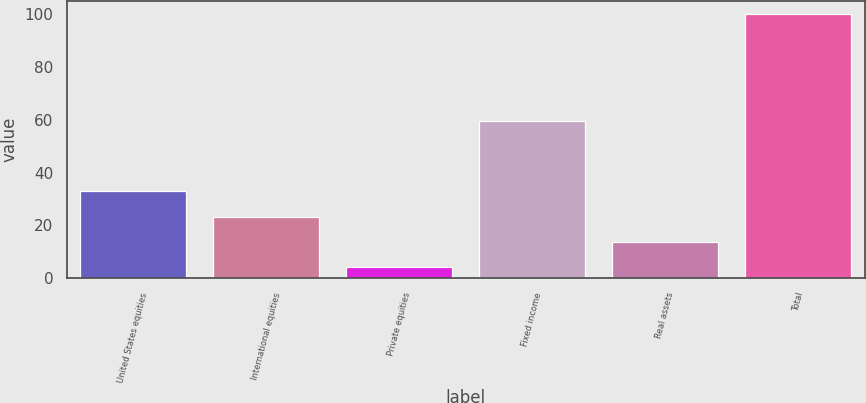Convert chart to OTSL. <chart><loc_0><loc_0><loc_500><loc_500><bar_chart><fcel>United States equities<fcel>International equities<fcel>Private equities<fcel>Fixed income<fcel>Real assets<fcel>Total<nl><fcel>32.94<fcel>23.36<fcel>4.2<fcel>59.6<fcel>13.78<fcel>100<nl></chart> 